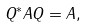Convert formula to latex. <formula><loc_0><loc_0><loc_500><loc_500>Q ^ { * } A Q = A ,</formula> 